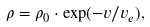Convert formula to latex. <formula><loc_0><loc_0><loc_500><loc_500>\rho = \rho _ { 0 } \cdot \exp ( - v / v _ { e } ) ,</formula> 